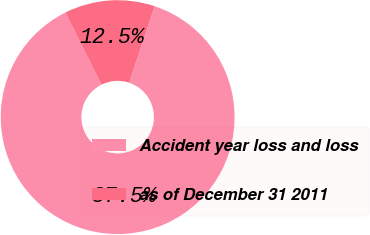Convert chart to OTSL. <chart><loc_0><loc_0><loc_500><loc_500><pie_chart><fcel>Accident year loss and loss<fcel>as of December 31 2011<nl><fcel>87.5%<fcel>12.5%<nl></chart> 